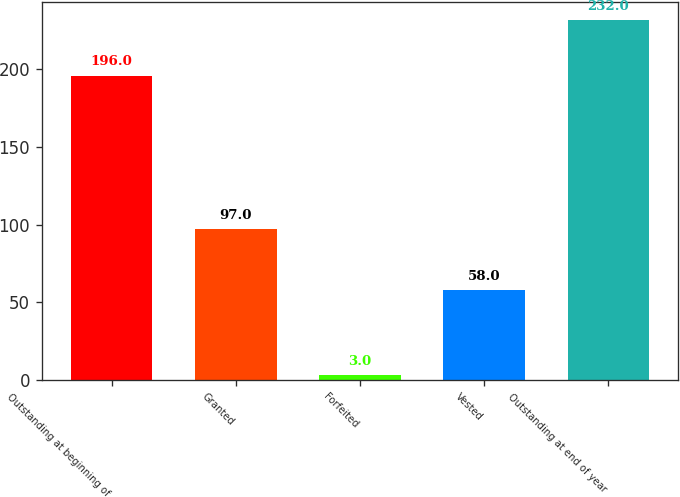Convert chart to OTSL. <chart><loc_0><loc_0><loc_500><loc_500><bar_chart><fcel>Outstanding at beginning of<fcel>Granted<fcel>Forfeited<fcel>Vested<fcel>Outstanding at end of year<nl><fcel>196<fcel>97<fcel>3<fcel>58<fcel>232<nl></chart> 